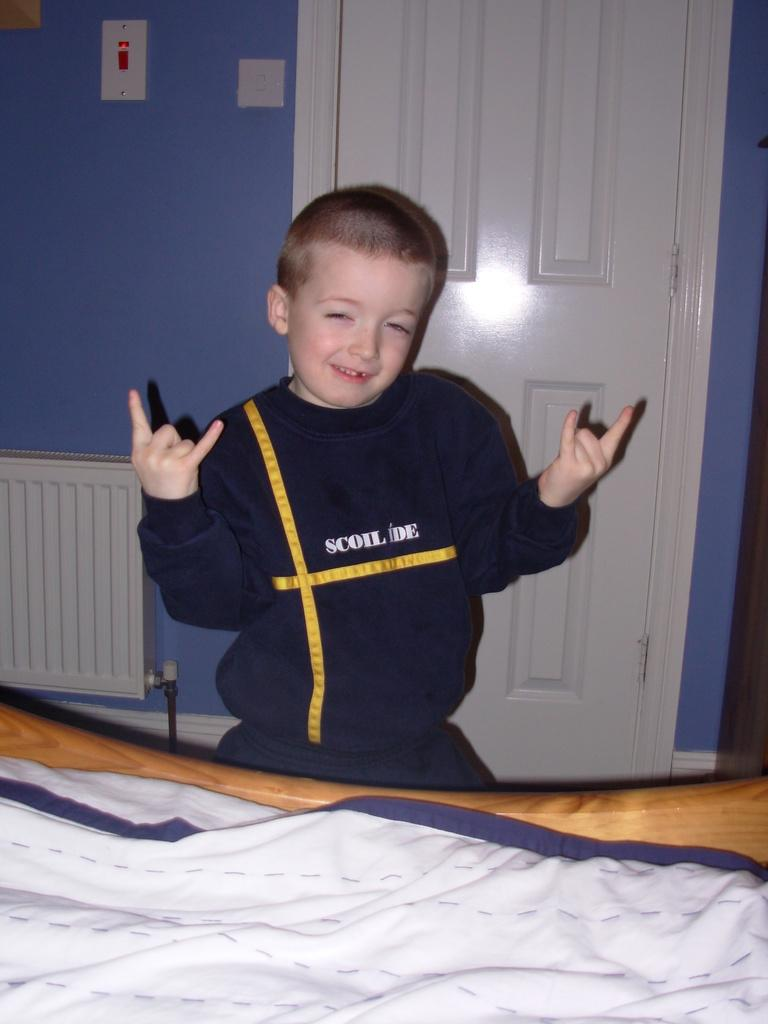<image>
Summarize the visual content of the image. A boy throws up the double rockers while wearing a shirt that says Scoil Ide. 